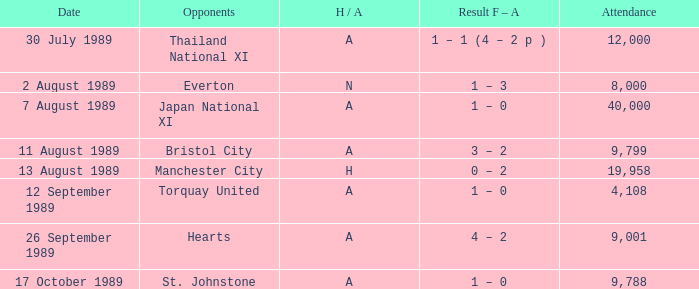When did manchester united have an away game against bristol city? 11 August 1989. 